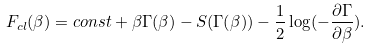Convert formula to latex. <formula><loc_0><loc_0><loc_500><loc_500>F _ { c l } ( \beta ) = c o n s t + \beta \Gamma ( \beta ) - S ( \Gamma ( \beta ) ) - \frac { 1 } { 2 } \log ( - \frac { \partial \Gamma } { \partial \beta } ) .</formula> 